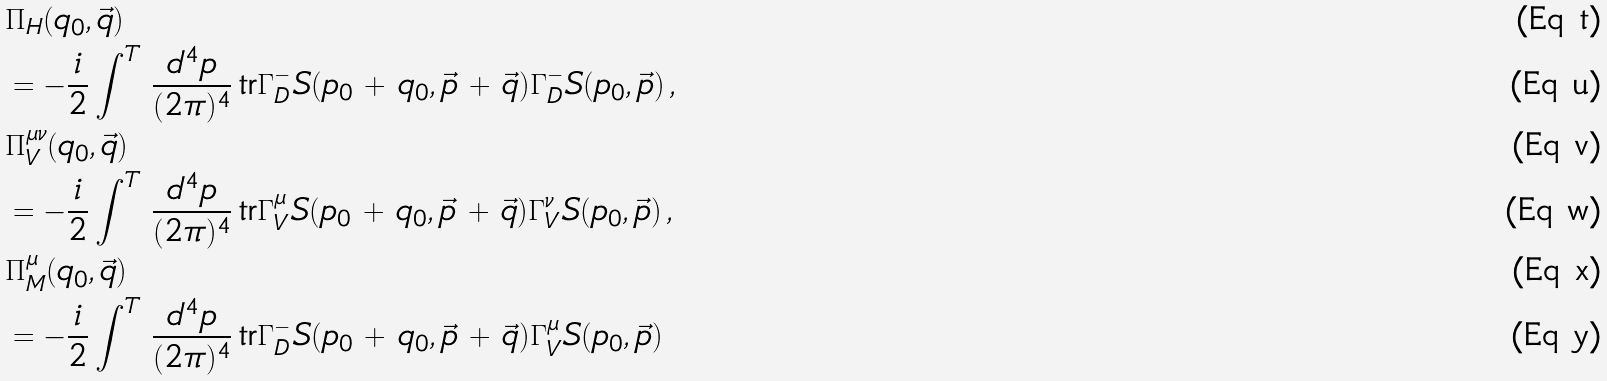<formula> <loc_0><loc_0><loc_500><loc_500>& \Pi _ { H } ( q _ { 0 } , \vec { q } ) \\ & = - \frac { i } { 2 } \int ^ { T } \, \frac { d ^ { 4 } p } { ( 2 \pi ) ^ { 4 } } \, \text {tr} \Gamma _ { D } ^ { - } S ( p _ { 0 } \, + \, q _ { 0 } , \vec { p } \, + \, \vec { q } ) \Gamma _ { D } ^ { - } S ( p _ { 0 } , \vec { p } ) \, , \\ & \Pi _ { V } ^ { \mu \nu } ( q _ { 0 } , \vec { q } ) \\ & = - \frac { i } { 2 } \int ^ { T } \, \frac { d ^ { 4 } p } { ( 2 \pi ) ^ { 4 } } \, \text {tr} \Gamma ^ { \mu } _ { V } S ( p _ { 0 } \, + \, q _ { 0 } , \vec { p } \, + \, \vec { q } ) \Gamma ^ { \nu } _ { V } S ( p _ { 0 } , \vec { p } ) \, , \\ & \Pi ^ { \mu } _ { M } ( q _ { 0 } , \vec { q } ) \\ & = - \frac { i } { 2 } \int ^ { T } \, \frac { d ^ { 4 } p } { ( 2 \pi ) ^ { 4 } } \, \text {tr} \Gamma _ { D } ^ { - } S ( p _ { 0 } \, + \, q _ { 0 } , \vec { p } \, + \, \vec { q } ) \Gamma ^ { \mu } _ { V } S ( p _ { 0 } , \vec { p } )</formula> 